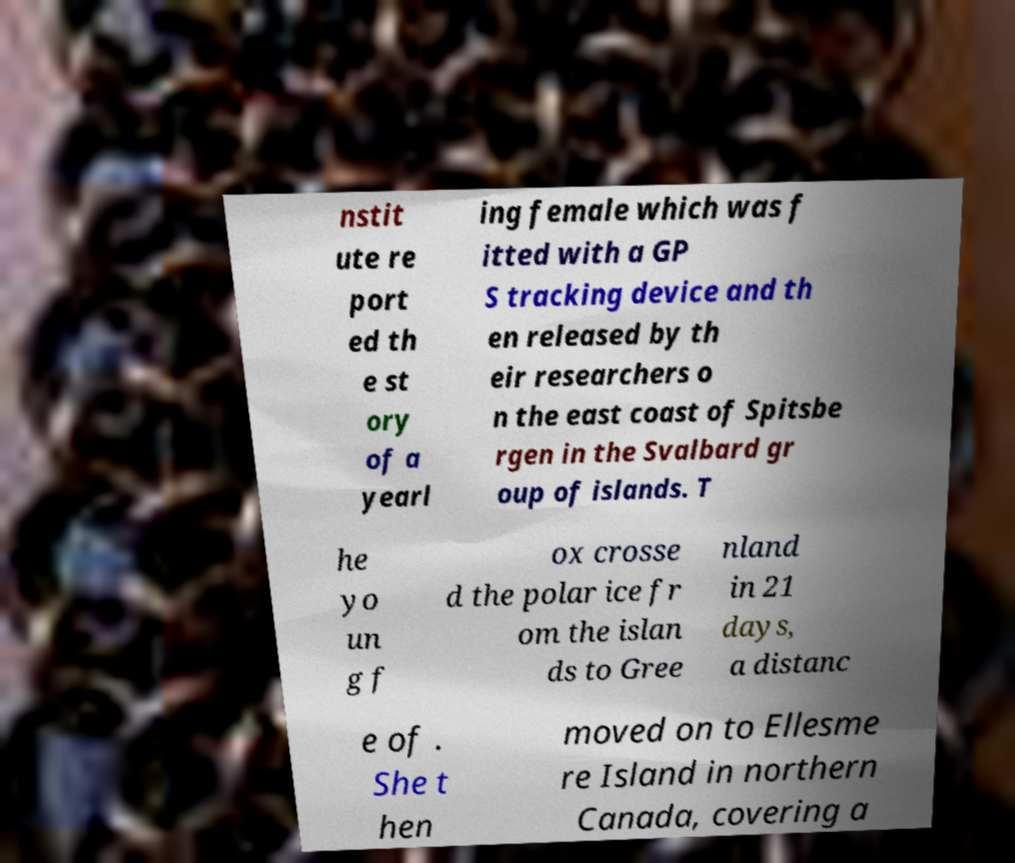What messages or text are displayed in this image? I need them in a readable, typed format. nstit ute re port ed th e st ory of a yearl ing female which was f itted with a GP S tracking device and th en released by th eir researchers o n the east coast of Spitsbe rgen in the Svalbard gr oup of islands. T he yo un g f ox crosse d the polar ice fr om the islan ds to Gree nland in 21 days, a distanc e of . She t hen moved on to Ellesme re Island in northern Canada, covering a 